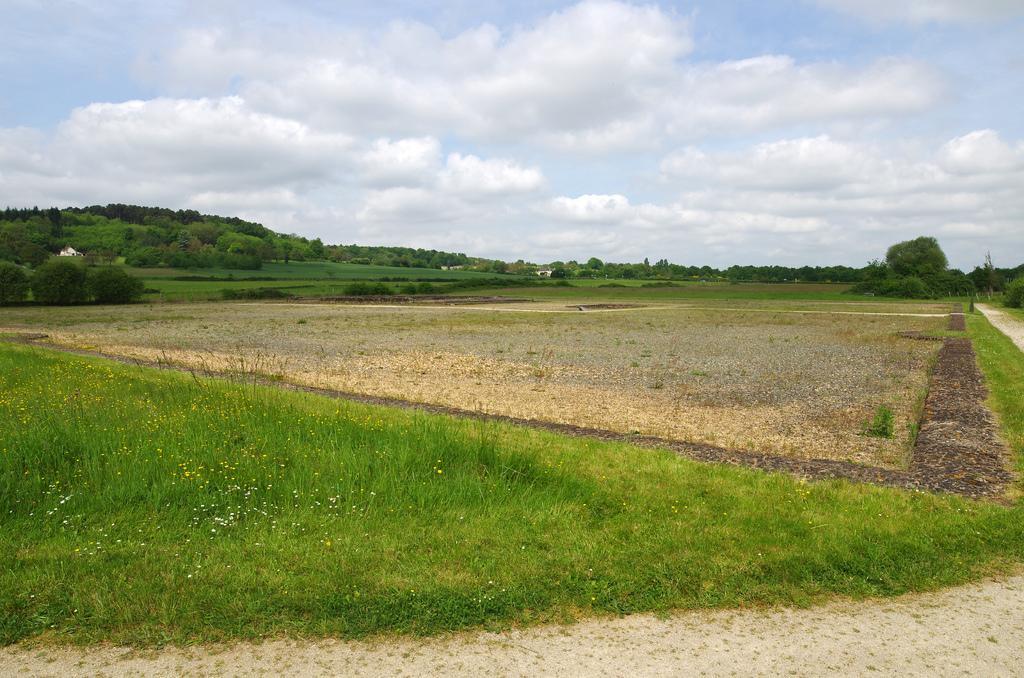Could you give a brief overview of what you see in this image? In this image we can see there are grass, trees, mountains and sky with clouds. 